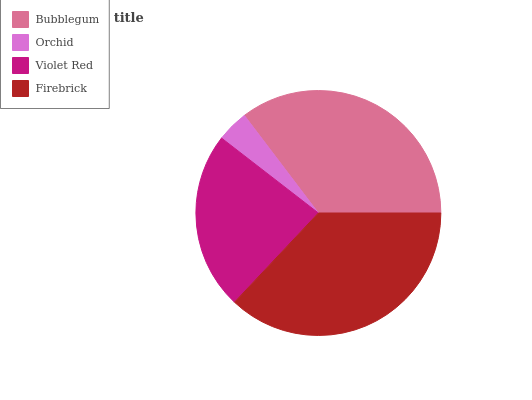Is Orchid the minimum?
Answer yes or no. Yes. Is Firebrick the maximum?
Answer yes or no. Yes. Is Violet Red the minimum?
Answer yes or no. No. Is Violet Red the maximum?
Answer yes or no. No. Is Violet Red greater than Orchid?
Answer yes or no. Yes. Is Orchid less than Violet Red?
Answer yes or no. Yes. Is Orchid greater than Violet Red?
Answer yes or no. No. Is Violet Red less than Orchid?
Answer yes or no. No. Is Bubblegum the high median?
Answer yes or no. Yes. Is Violet Red the low median?
Answer yes or no. Yes. Is Violet Red the high median?
Answer yes or no. No. Is Bubblegum the low median?
Answer yes or no. No. 